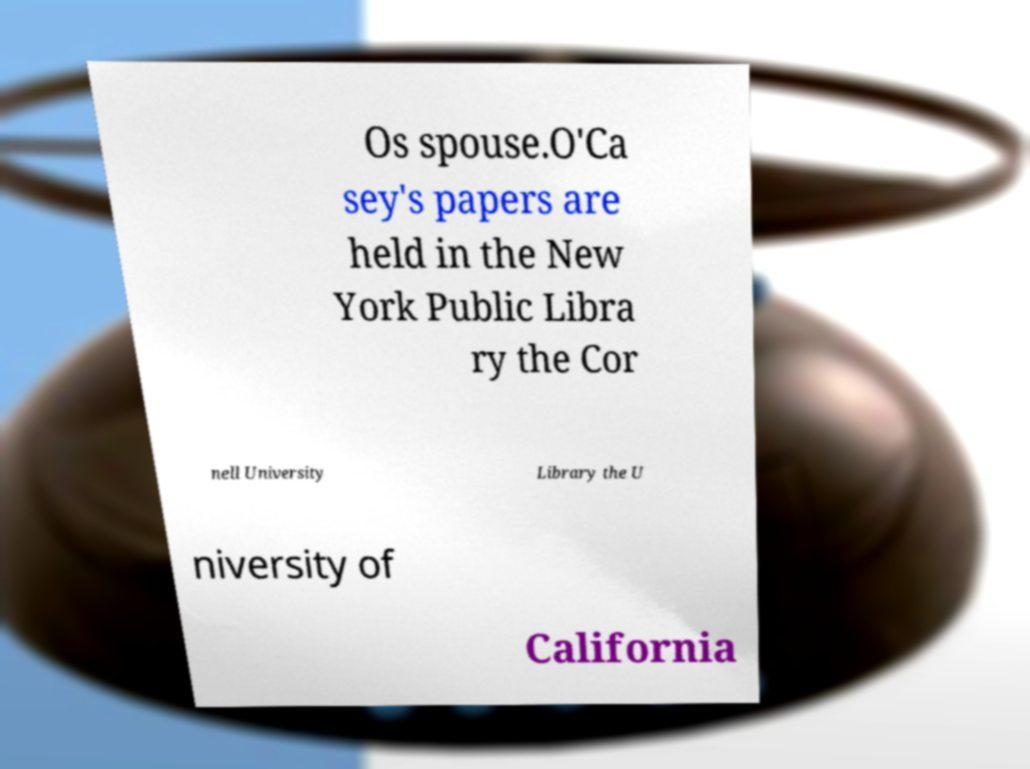What messages or text are displayed in this image? I need them in a readable, typed format. Os spouse.O'Ca sey's papers are held in the New York Public Libra ry the Cor nell University Library the U niversity of California 